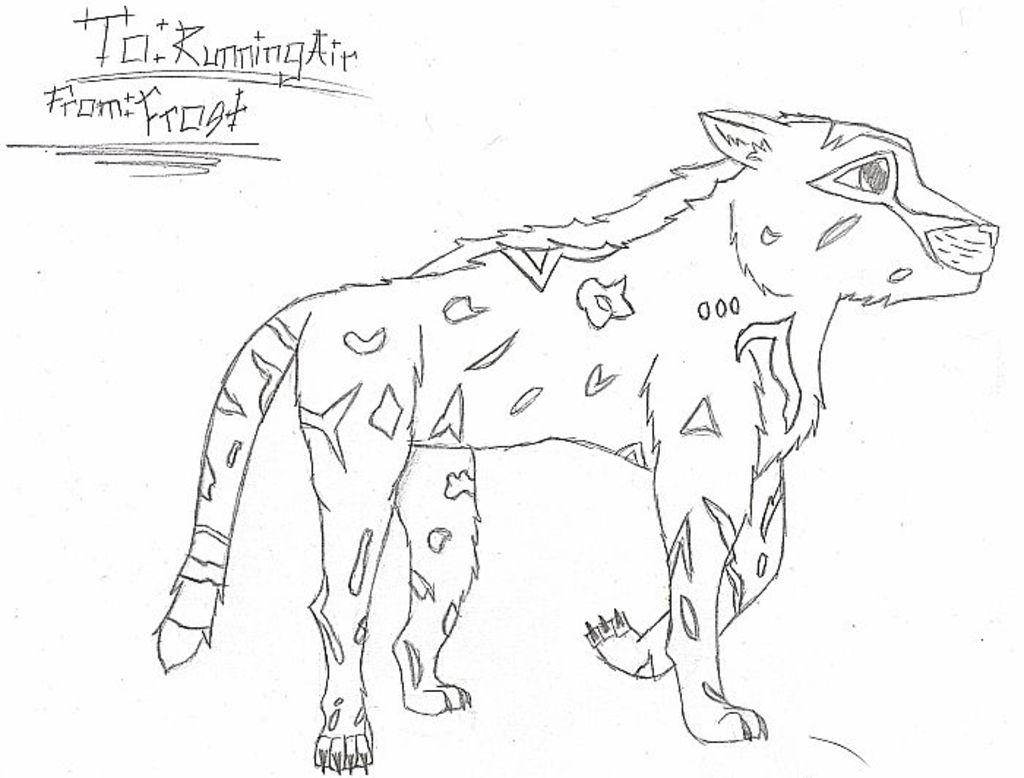What is depicted in the image? There is a sketch of a wild animal in the image. What else can be seen in the image besides the sketch? There is some text at the top of the image. What stage of development is the monkey in the image? There is no monkey present in the image; it features a sketch of a wild animal. What type of crush is the person in the image experiencing? There is no person or mention of a crush in the image; it features a sketch of a wild animal and some text. 